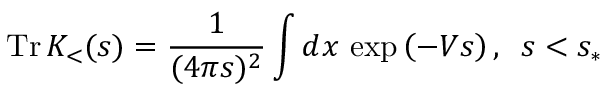<formula> <loc_0><loc_0><loc_500><loc_500>T r \, K _ { < } ( s ) = \frac { 1 } { ( 4 \pi s ) ^ { 2 } } \int d x \, \exp \left ( - V s \right ) , \, s < s _ { \ast }</formula> 